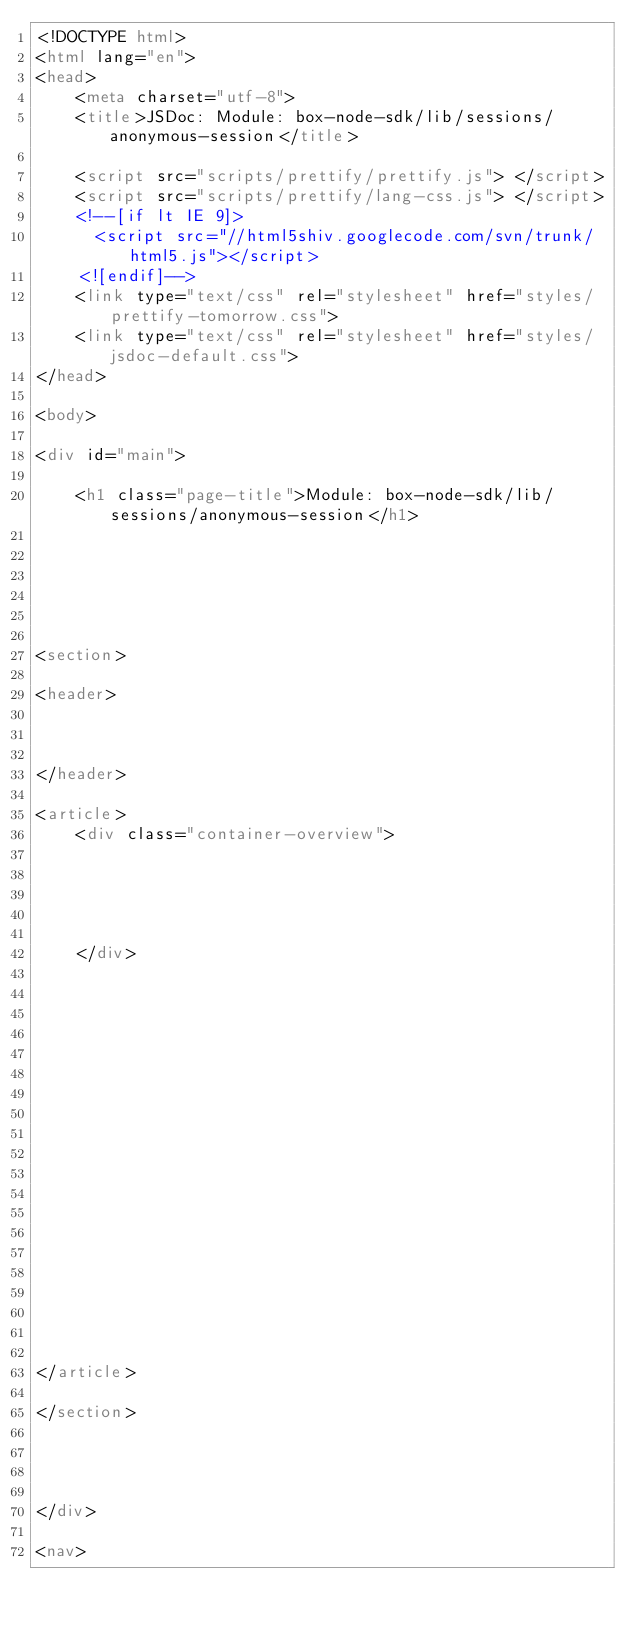<code> <loc_0><loc_0><loc_500><loc_500><_HTML_><!DOCTYPE html>
<html lang="en">
<head>
    <meta charset="utf-8">
    <title>JSDoc: Module: box-node-sdk/lib/sessions/anonymous-session</title>

    <script src="scripts/prettify/prettify.js"> </script>
    <script src="scripts/prettify/lang-css.js"> </script>
    <!--[if lt IE 9]>
      <script src="//html5shiv.googlecode.com/svn/trunk/html5.js"></script>
    <![endif]-->
    <link type="text/css" rel="stylesheet" href="styles/prettify-tomorrow.css">
    <link type="text/css" rel="stylesheet" href="styles/jsdoc-default.css">
</head>

<body>

<div id="main">

    <h1 class="page-title">Module: box-node-sdk/lib/sessions/anonymous-session</h1>

    




<section>

<header>
    
        
    
</header>

<article>
    <div class="container-overview">
    
        

        
    
    </div>

    

    

    

    

    

    

    

    

    

    
</article>

</section>




</div>

<nav></code> 